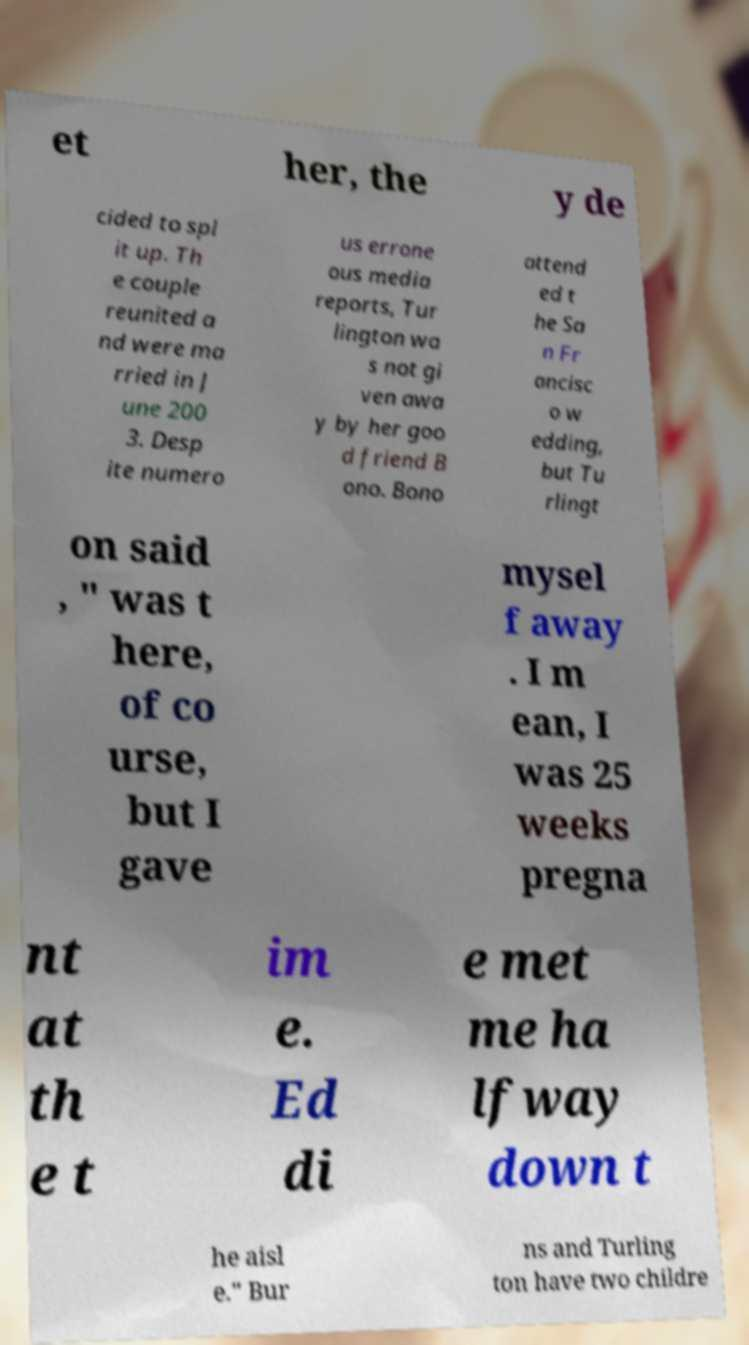There's text embedded in this image that I need extracted. Can you transcribe it verbatim? et her, the y de cided to spl it up. Th e couple reunited a nd were ma rried in J une 200 3. Desp ite numero us errone ous media reports, Tur lington wa s not gi ven awa y by her goo d friend B ono. Bono attend ed t he Sa n Fr ancisc o w edding, but Tu rlingt on said , " was t here, of co urse, but I gave mysel f away . I m ean, I was 25 weeks pregna nt at th e t im e. Ed di e met me ha lfway down t he aisl e." Bur ns and Turling ton have two childre 